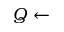<formula> <loc_0><loc_0><loc_500><loc_500>Q \leftarrow</formula> 